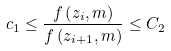Convert formula to latex. <formula><loc_0><loc_0><loc_500><loc_500>c _ { 1 } \leq \frac { f \left ( z _ { i } , m \right ) } { f \left ( z _ { i + 1 } , m \right ) } \leq C _ { 2 }</formula> 